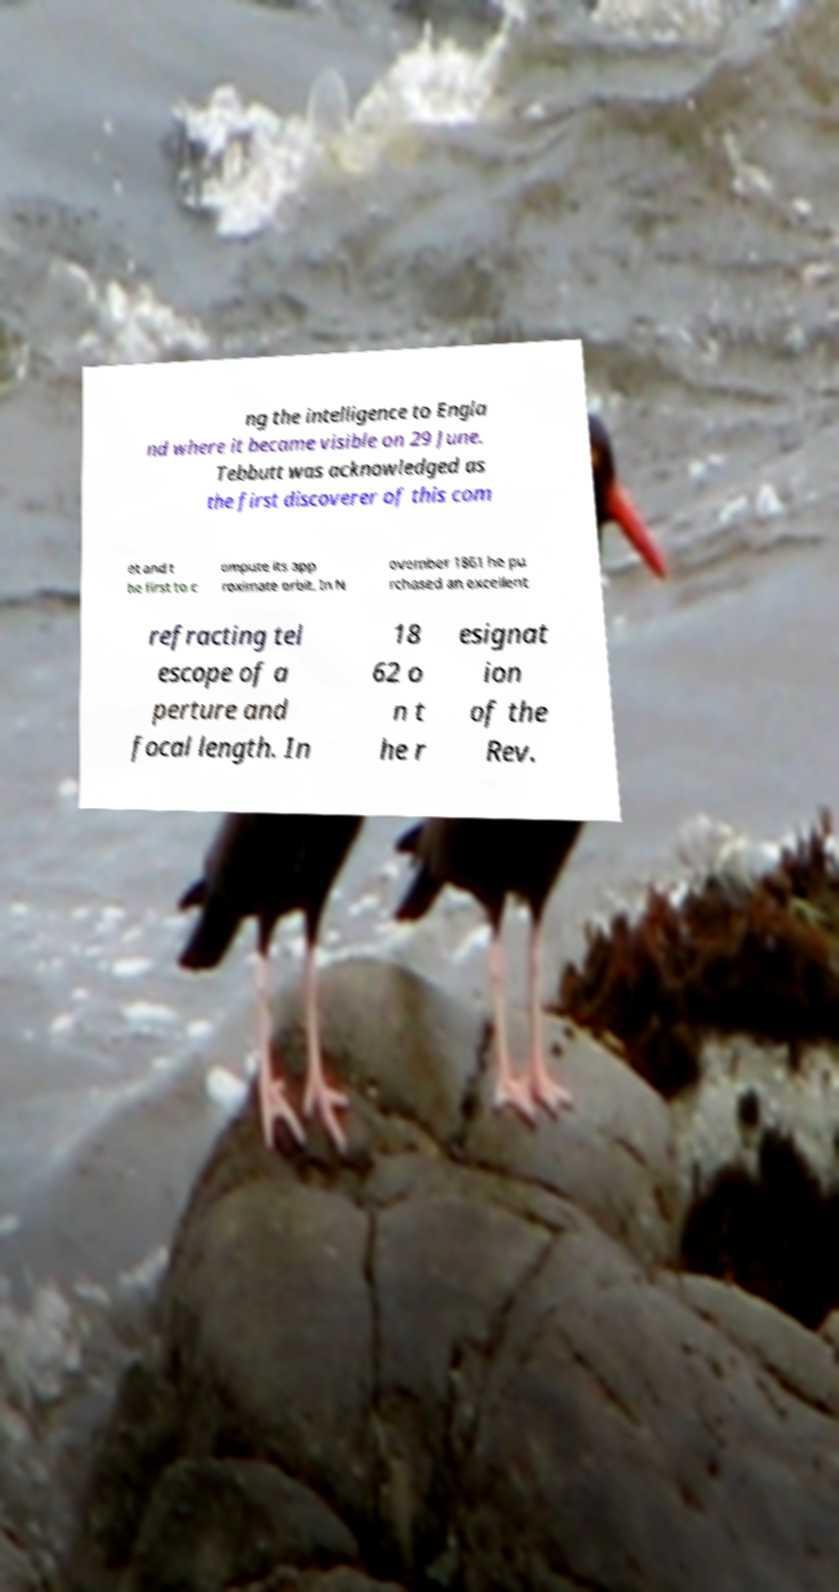There's text embedded in this image that I need extracted. Can you transcribe it verbatim? ng the intelligence to Engla nd where it became visible on 29 June. Tebbutt was acknowledged as the first discoverer of this com et and t he first to c ompute its app roximate orbit. In N ovember 1861 he pu rchased an excellent refracting tel escope of a perture and focal length. In 18 62 o n t he r esignat ion of the Rev. 